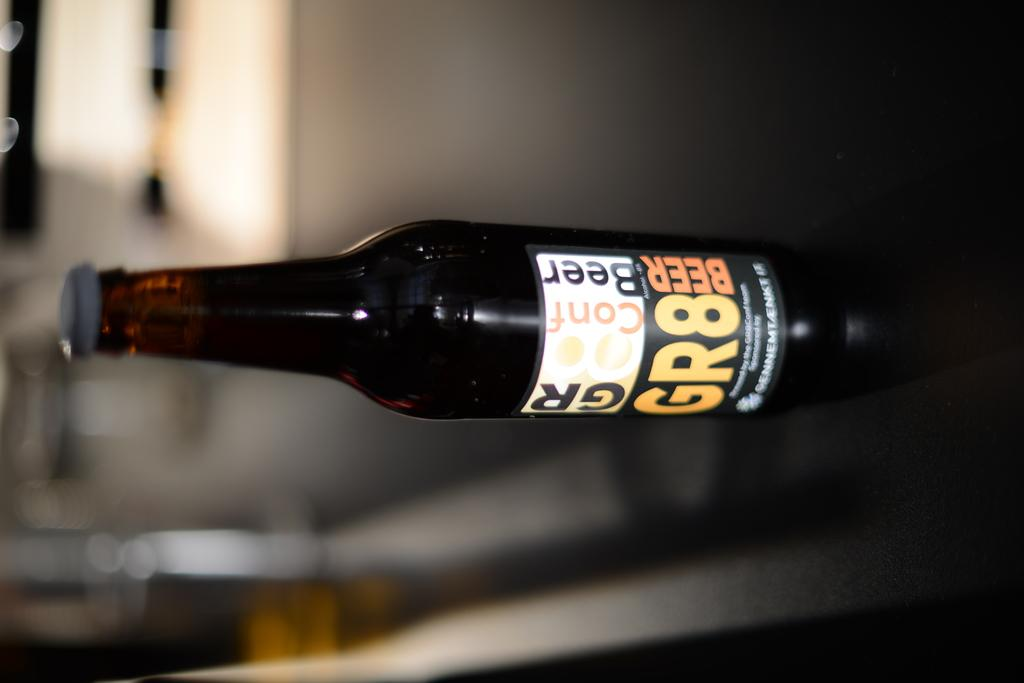<image>
Present a compact description of the photo's key features. A bottle of beer says that it is GR8. 